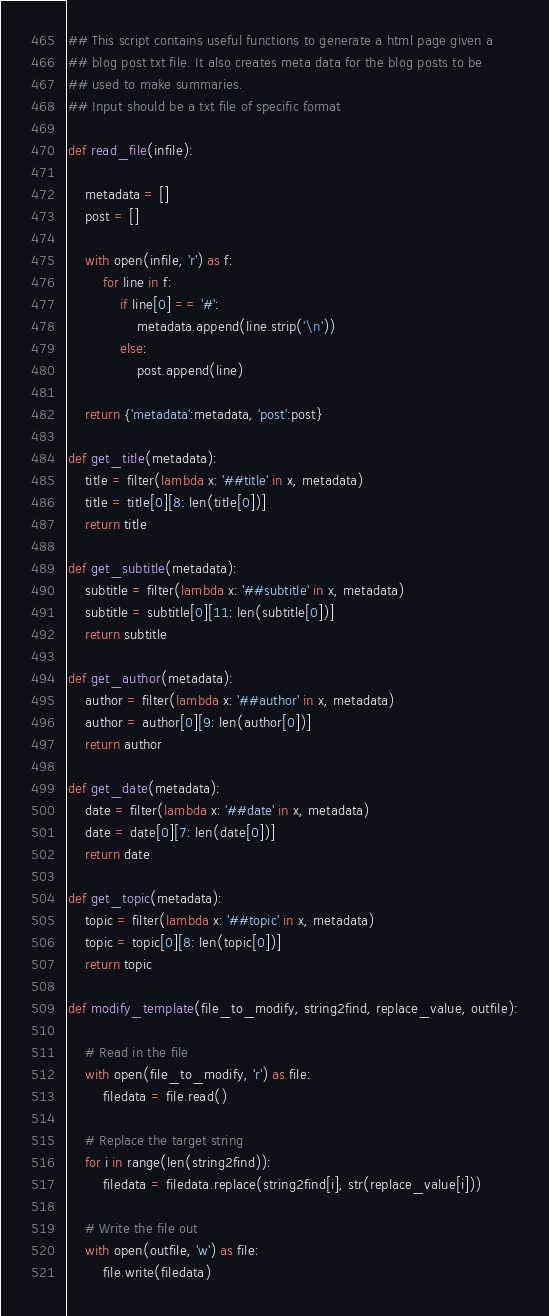<code> <loc_0><loc_0><loc_500><loc_500><_Python_>## This script contains useful functions to generate a html page given a 
## blog post txt file. It also creates meta data for the blog posts to be 
## used to make summaries.
## Input should be a txt file of specific format 

def read_file(infile):

    metadata = []
    post = []

    with open(infile, 'r') as f:
        for line in f:
            if line[0] == '#':
                metadata.append(line.strip('\n'))
            else:
                post.append(line)

    return {'metadata':metadata, 'post':post}

def get_title(metadata):
    title = filter(lambda x: '##title' in x, metadata)
    title = title[0][8: len(title[0])]
    return title

def get_subtitle(metadata):
    subtitle = filter(lambda x: '##subtitle' in x, metadata)
    subtitle = subtitle[0][11: len(subtitle[0])]
    return subtitle

def get_author(metadata):
    author = filter(lambda x: '##author' in x, metadata)
    author = author[0][9: len(author[0])]
    return author

def get_date(metadata):
    date = filter(lambda x: '##date' in x, metadata)
    date = date[0][7: len(date[0])]
    return date

def get_topic(metadata):
    topic = filter(lambda x: '##topic' in x, metadata)
    topic = topic[0][8: len(topic[0])]
    return topic

def modify_template(file_to_modify, string2find, replace_value, outfile):
    
    # Read in the file
    with open(file_to_modify, 'r') as file:
        filedata = file.read()
        
    # Replace the target string
    for i in range(len(string2find)):
        filedata = filedata.replace(string2find[i], str(replace_value[i]))
        
    # Write the file out
    with open(outfile, 'w') as file:
        file.write(filedata)</code> 